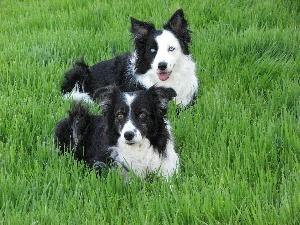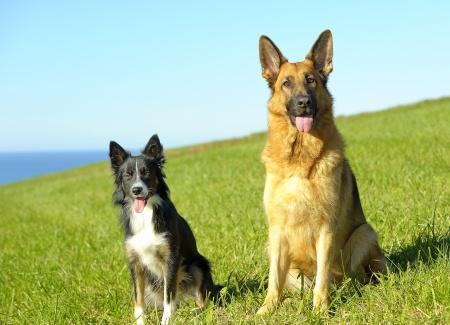The first image is the image on the left, the second image is the image on the right. Given the left and right images, does the statement "There are at least four dogs in total." hold true? Answer yes or no. Yes. The first image is the image on the left, the second image is the image on the right. Evaluate the accuracy of this statement regarding the images: "in the left image there is a do with the left ear up and the right ear down". Is it true? Answer yes or no. No. 